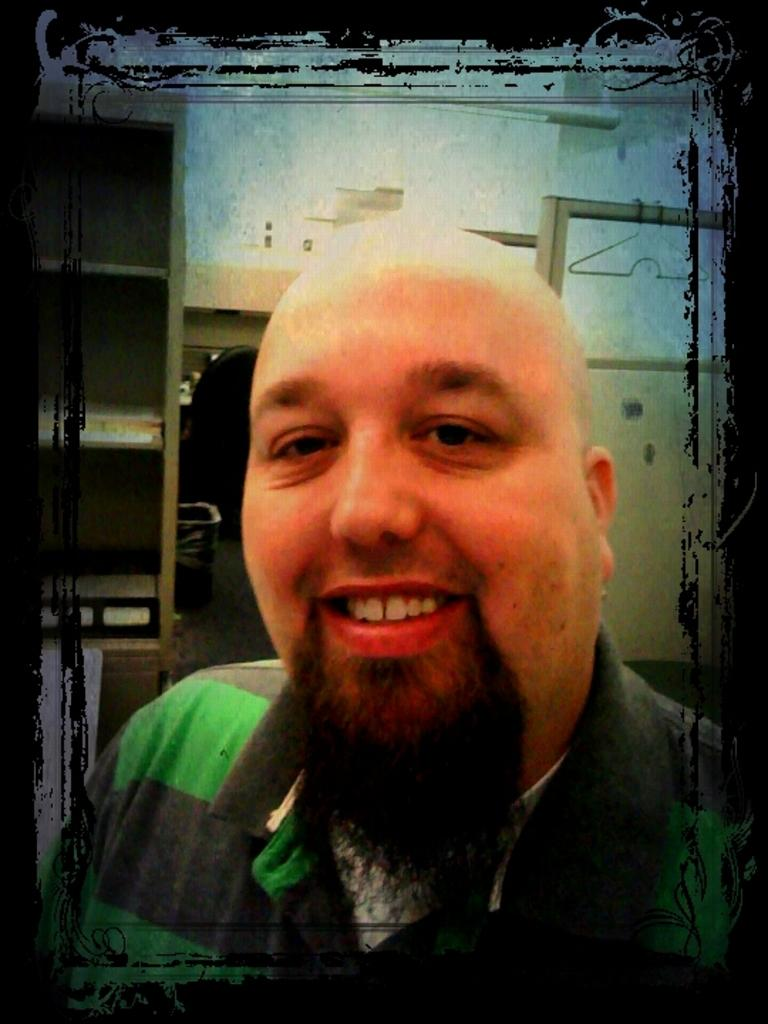What is the person in the image wearing? The person is wearing a T-shirt. What is the person's facial expression in the image? The person is smiling. What can be seen in the background of the image? There are cupboards, a dustbin, a chair, and a hanger in the background of the image. What is present in the image besides the person? There is a frame in the image. What type of line is visible on the mailbox in the image? There is no mailbox present in the image. What is the caption of the image? There is no caption present in the image. 